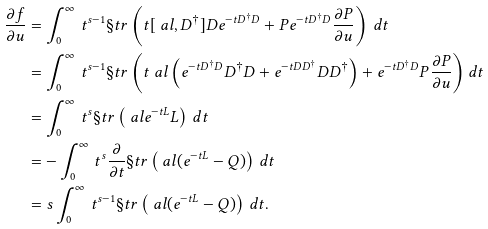<formula> <loc_0><loc_0><loc_500><loc_500>\frac { \partial f } { \partial u } & = \int _ { 0 } ^ { \infty } \, t ^ { s - 1 } \S t r \left ( t [ \ a l , D ^ { \dagger } ] D e ^ { - t D ^ { \dagger } D } + P e ^ { - t D ^ { \dagger } D } \frac { \partial P } { \partial u } \right ) \, d t \\ & = \int _ { 0 } ^ { \infty } \, t ^ { s - 1 } \S t r \left ( t \ a l \left ( e ^ { - t D ^ { \dagger } D } D ^ { \dagger } D + e ^ { - t D D ^ { \dagger } } D D ^ { \dagger } \right ) + e ^ { - t D ^ { \dagger } D } P \frac { \partial P } { \partial u } \right ) d t \\ & = \int _ { 0 } ^ { \infty } \, t ^ { s } \S t r \left ( \ a l e ^ { - t L } L \right ) \, d t \\ & = - \int _ { 0 } ^ { \infty } \, t ^ { s } \frac { \partial } { \partial t } \S t r \left ( \ a l ( e ^ { - t L } - Q ) \right ) \, d t \\ & = s \int _ { 0 } ^ { \infty } \, t ^ { s - 1 } \S t r \left ( \ a l ( e ^ { - t L } - Q ) \right ) \, d t .</formula> 